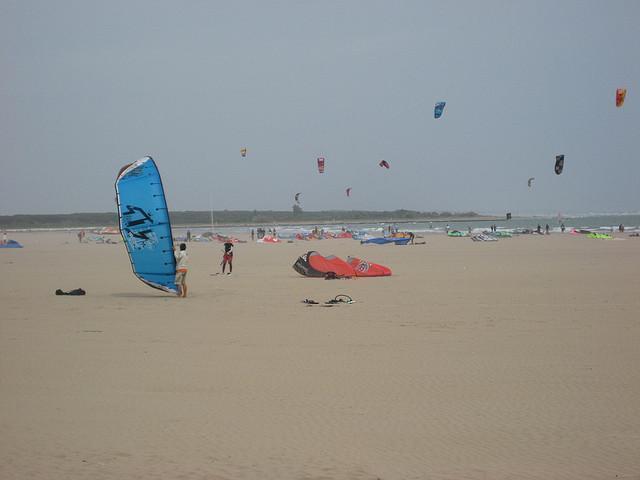How many kites are in the picture?
Give a very brief answer. 2. 